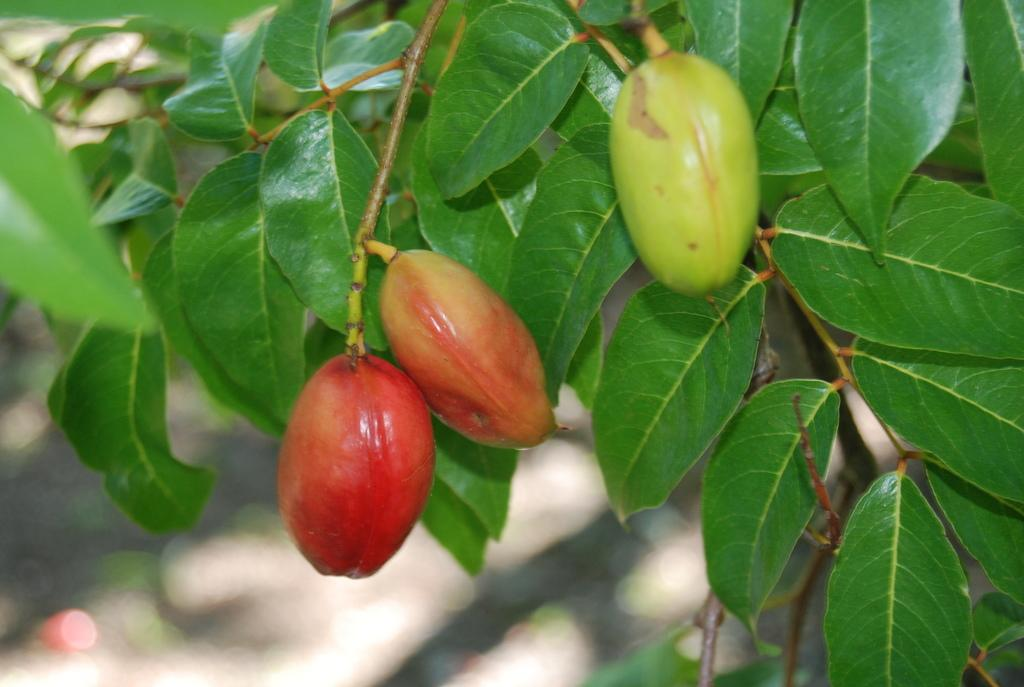What type of vegetation is present in the image? There are green color leaves in the image. What else can be seen in the image besides the leaves? There are stems in the image. How many fruits are visible in the image? There are three fruits in the image. Can you describe the background of the image? The background of the image is blurry. Can you see a kitty kissing a finger in the image? There is no kitty, kiss, or finger present in the image. 